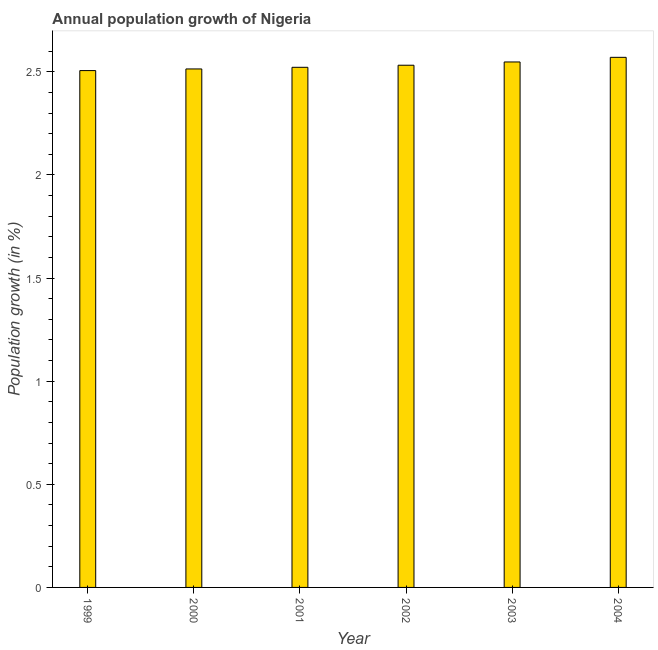What is the title of the graph?
Your response must be concise. Annual population growth of Nigeria. What is the label or title of the X-axis?
Ensure brevity in your answer.  Year. What is the label or title of the Y-axis?
Offer a terse response. Population growth (in %). What is the population growth in 2002?
Your response must be concise. 2.53. Across all years, what is the maximum population growth?
Your answer should be compact. 2.57. Across all years, what is the minimum population growth?
Offer a terse response. 2.51. In which year was the population growth minimum?
Keep it short and to the point. 1999. What is the sum of the population growth?
Provide a succinct answer. 15.19. What is the difference between the population growth in 1999 and 2004?
Provide a short and direct response. -0.06. What is the average population growth per year?
Ensure brevity in your answer.  2.53. What is the median population growth?
Provide a short and direct response. 2.53. Do a majority of the years between 2003 and 2001 (inclusive) have population growth greater than 0.9 %?
Your answer should be compact. Yes. What is the ratio of the population growth in 2002 to that in 2003?
Offer a very short reply. 0.99. Is the difference between the population growth in 1999 and 2004 greater than the difference between any two years?
Provide a succinct answer. Yes. What is the difference between the highest and the second highest population growth?
Provide a short and direct response. 0.02. In how many years, is the population growth greater than the average population growth taken over all years?
Offer a terse response. 2. How many bars are there?
Your answer should be compact. 6. Are the values on the major ticks of Y-axis written in scientific E-notation?
Provide a short and direct response. No. What is the Population growth (in %) of 1999?
Your response must be concise. 2.51. What is the Population growth (in %) of 2000?
Your response must be concise. 2.51. What is the Population growth (in %) in 2001?
Provide a succinct answer. 2.52. What is the Population growth (in %) of 2002?
Offer a terse response. 2.53. What is the Population growth (in %) of 2003?
Keep it short and to the point. 2.55. What is the Population growth (in %) in 2004?
Provide a short and direct response. 2.57. What is the difference between the Population growth (in %) in 1999 and 2000?
Your answer should be very brief. -0.01. What is the difference between the Population growth (in %) in 1999 and 2001?
Provide a short and direct response. -0.02. What is the difference between the Population growth (in %) in 1999 and 2002?
Offer a terse response. -0.03. What is the difference between the Population growth (in %) in 1999 and 2003?
Provide a short and direct response. -0.04. What is the difference between the Population growth (in %) in 1999 and 2004?
Provide a short and direct response. -0.06. What is the difference between the Population growth (in %) in 2000 and 2001?
Offer a very short reply. -0.01. What is the difference between the Population growth (in %) in 2000 and 2002?
Keep it short and to the point. -0.02. What is the difference between the Population growth (in %) in 2000 and 2003?
Your answer should be compact. -0.03. What is the difference between the Population growth (in %) in 2000 and 2004?
Your answer should be very brief. -0.06. What is the difference between the Population growth (in %) in 2001 and 2002?
Ensure brevity in your answer.  -0.01. What is the difference between the Population growth (in %) in 2001 and 2003?
Your response must be concise. -0.03. What is the difference between the Population growth (in %) in 2001 and 2004?
Your answer should be very brief. -0.05. What is the difference between the Population growth (in %) in 2002 and 2003?
Offer a very short reply. -0.02. What is the difference between the Population growth (in %) in 2002 and 2004?
Provide a succinct answer. -0.04. What is the difference between the Population growth (in %) in 2003 and 2004?
Your answer should be very brief. -0.02. What is the ratio of the Population growth (in %) in 1999 to that in 2001?
Provide a short and direct response. 0.99. What is the ratio of the Population growth (in %) in 1999 to that in 2003?
Offer a terse response. 0.98. What is the ratio of the Population growth (in %) in 2000 to that in 2002?
Offer a very short reply. 0.99. What is the ratio of the Population growth (in %) in 2000 to that in 2004?
Offer a very short reply. 0.98. What is the ratio of the Population growth (in %) in 2001 to that in 2002?
Your answer should be compact. 1. What is the ratio of the Population growth (in %) in 2001 to that in 2003?
Your answer should be very brief. 0.99. What is the ratio of the Population growth (in %) in 2001 to that in 2004?
Your response must be concise. 0.98. What is the ratio of the Population growth (in %) in 2002 to that in 2004?
Your answer should be compact. 0.98. What is the ratio of the Population growth (in %) in 2003 to that in 2004?
Your response must be concise. 0.99. 